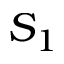Convert formula to latex. <formula><loc_0><loc_0><loc_500><loc_500>S _ { 1 }</formula> 